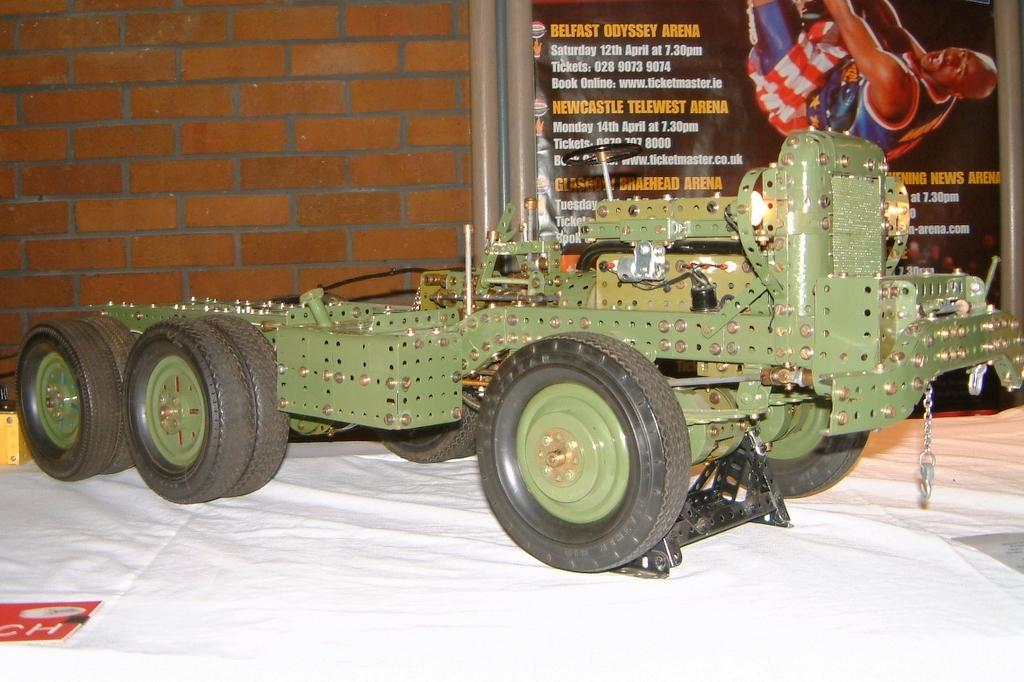What object is on the table in the image? There is a truck toy on the table. What can be seen in the background of the image? There is a banner with text and a picture of a man in the background. What is the banner located near in the image? The banner is beside a wall with bricks. What type of trade is being conducted in the image? There is no indication of any trade being conducted in the image. How does the man in the banner's picture feel about the event? The image does not provide any information about the man's feelings or the event being depicted. 